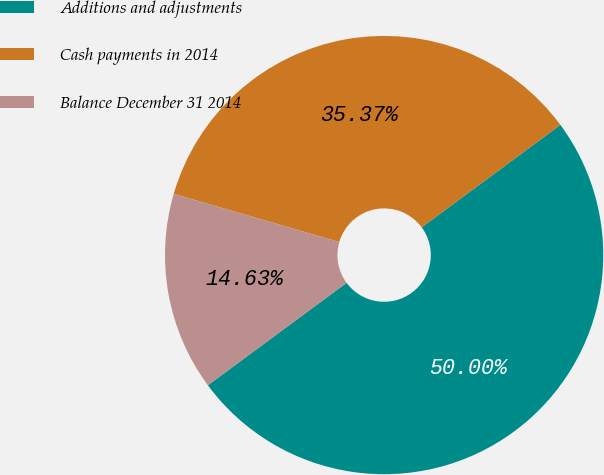Convert chart. <chart><loc_0><loc_0><loc_500><loc_500><pie_chart><fcel>Additions and adjustments<fcel>Cash payments in 2014<fcel>Balance December 31 2014<nl><fcel>50.0%<fcel>35.37%<fcel>14.63%<nl></chart> 